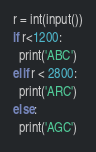<code> <loc_0><loc_0><loc_500><loc_500><_Python_>r = int(input())
if r<1200:
  print('ABC')
elif r < 2800:
  print('ARC')
else:
  print('AGC')


</code> 